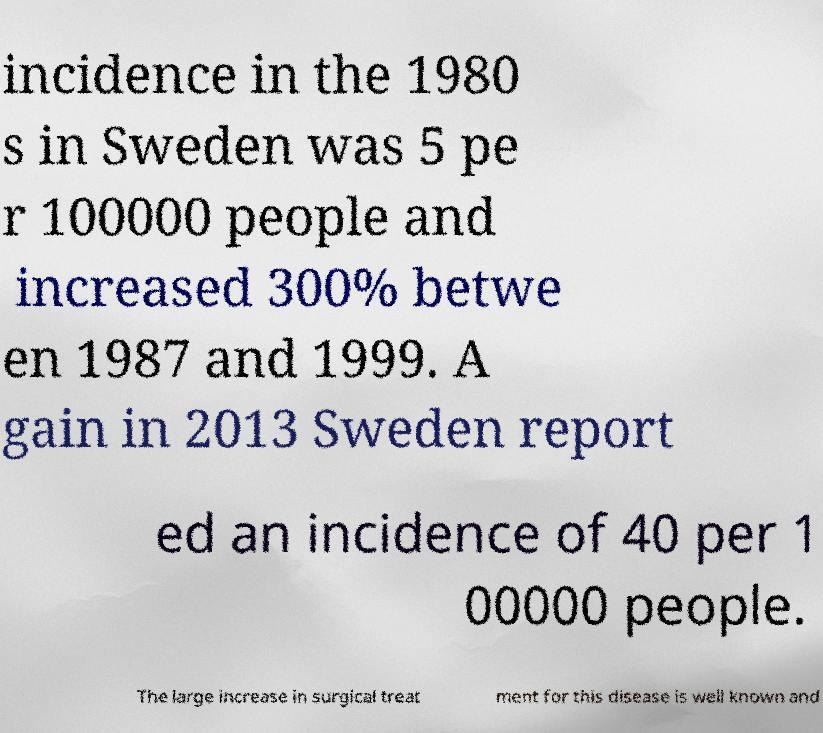For documentation purposes, I need the text within this image transcribed. Could you provide that? incidence in the 1980 s in Sweden was 5 pe r 100000 people and increased 300% betwe en 1987 and 1999. A gain in 2013 Sweden report ed an incidence of 40 per 1 00000 people. The large increase in surgical treat ment for this disease is well known and 